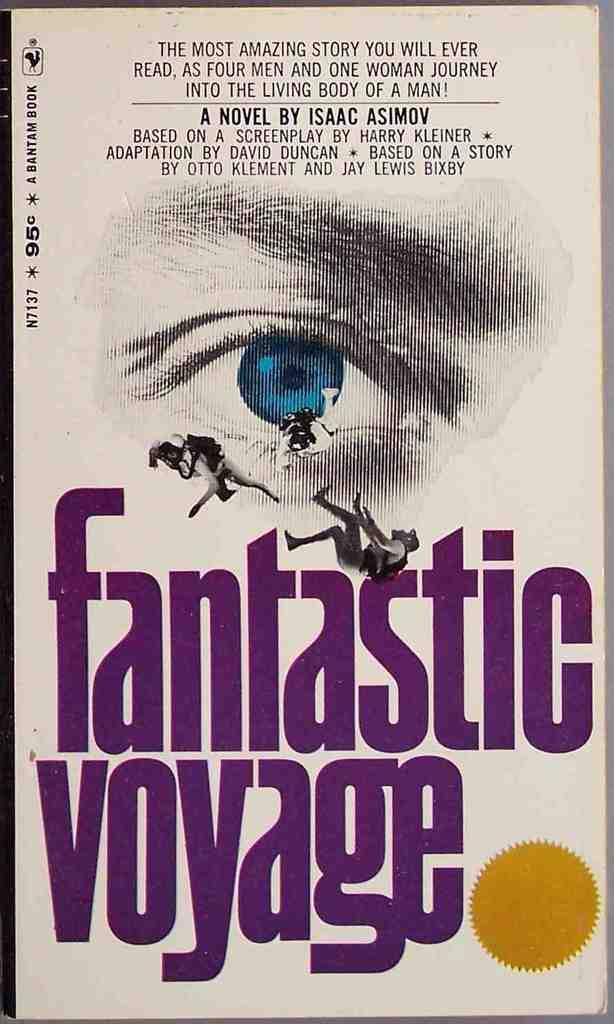What is the title of this book?
Provide a succinct answer. Fantastic voyage. Who was the author of this novel?
Offer a very short reply. Isaac asimov. 